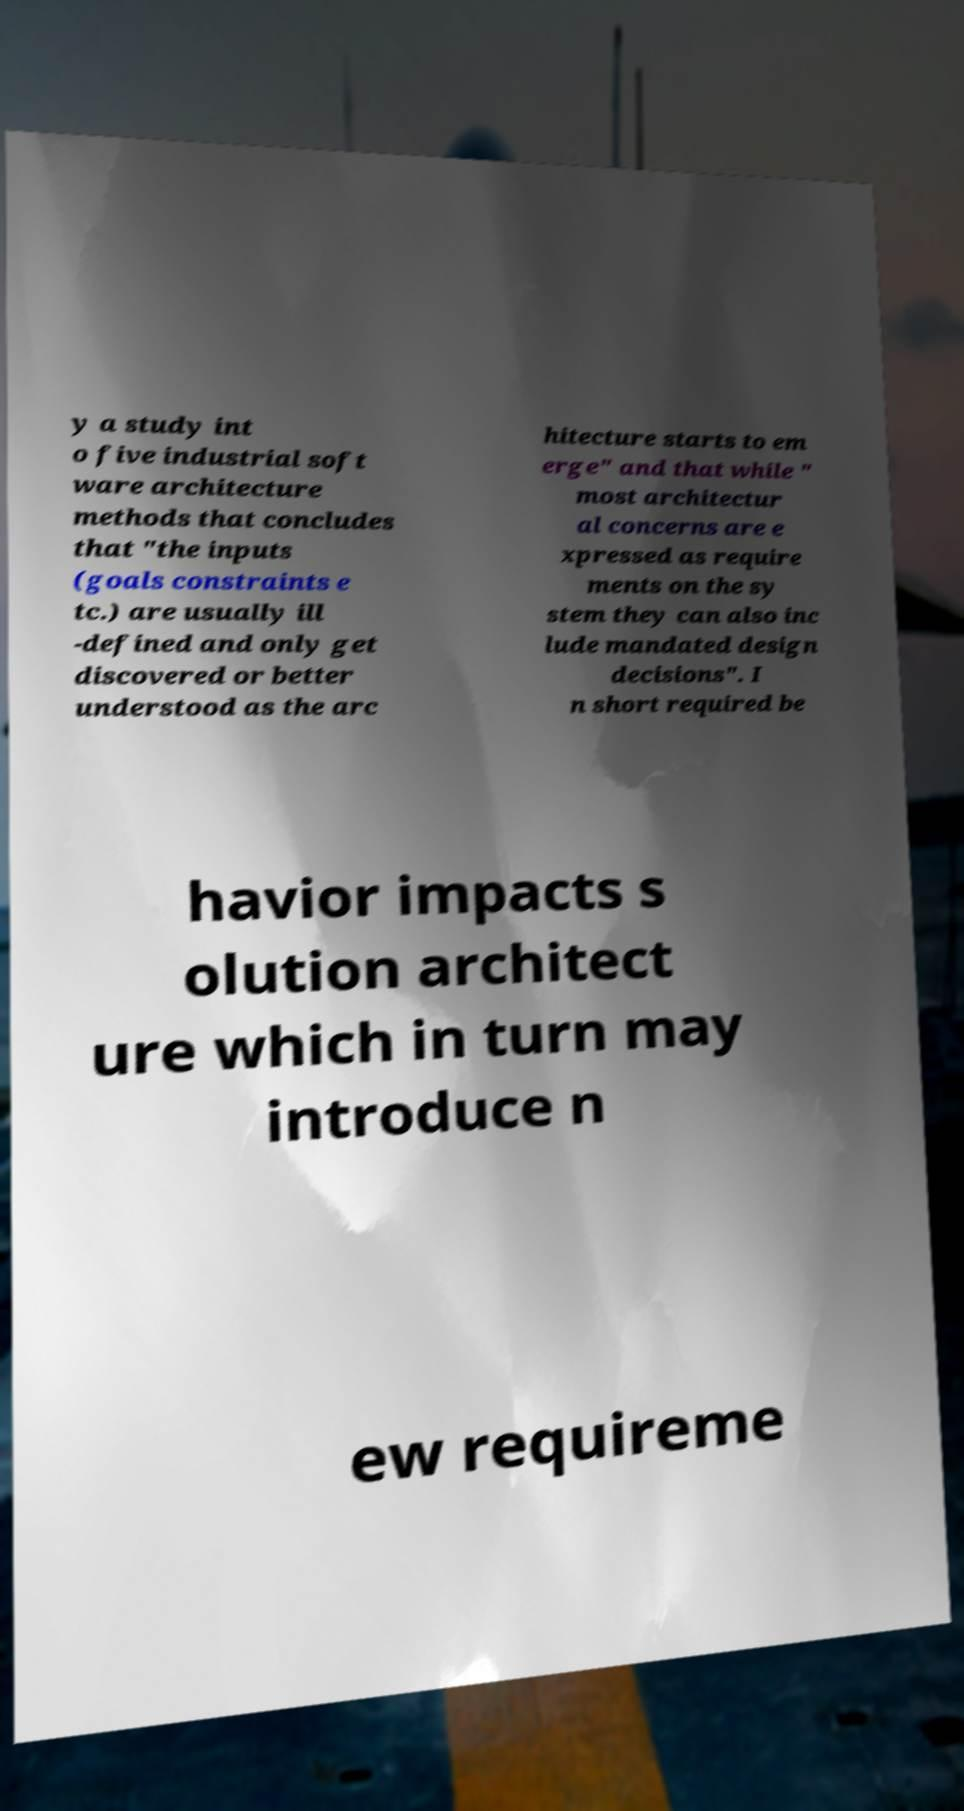Could you extract and type out the text from this image? y a study int o five industrial soft ware architecture methods that concludes that "the inputs (goals constraints e tc.) are usually ill -defined and only get discovered or better understood as the arc hitecture starts to em erge" and that while " most architectur al concerns are e xpressed as require ments on the sy stem they can also inc lude mandated design decisions". I n short required be havior impacts s olution architect ure which in turn may introduce n ew requireme 